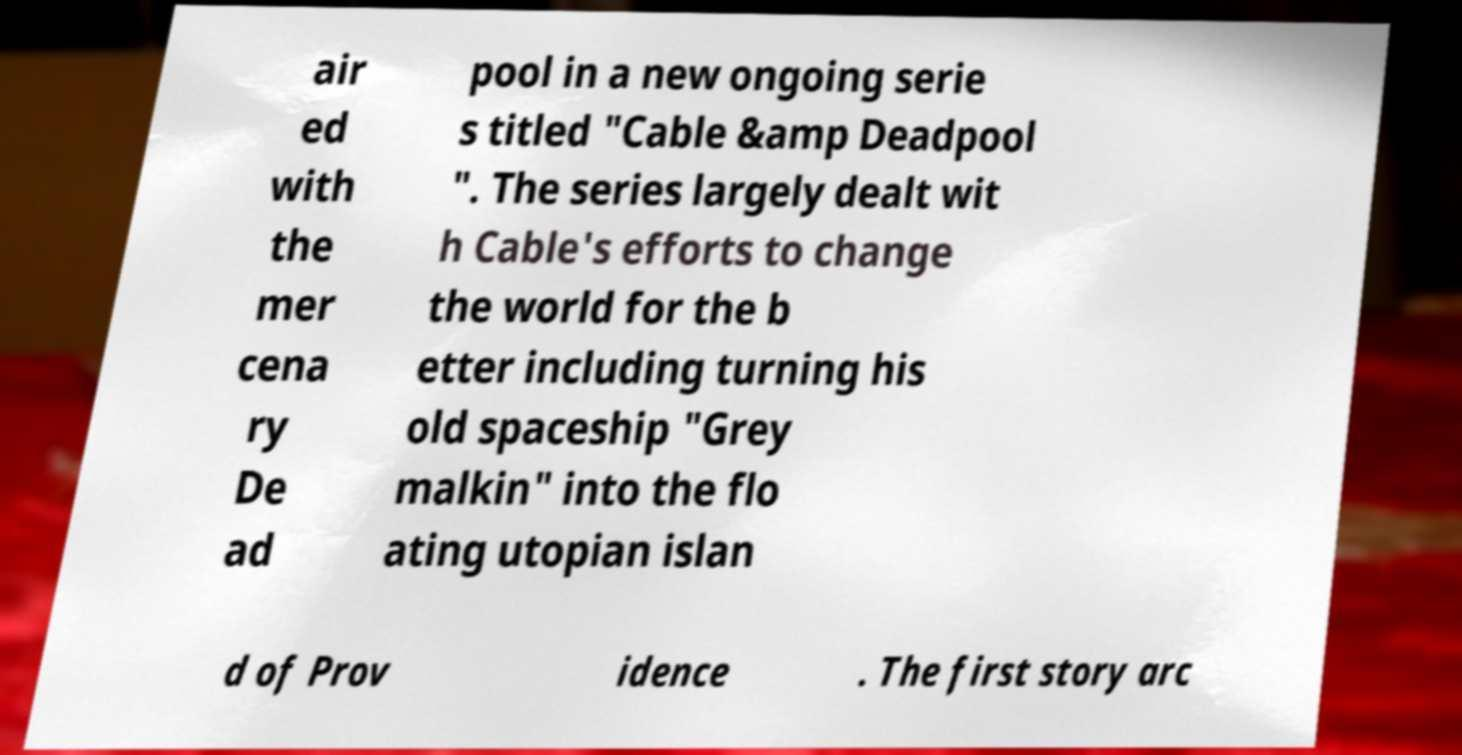Could you assist in decoding the text presented in this image and type it out clearly? air ed with the mer cena ry De ad pool in a new ongoing serie s titled "Cable &amp Deadpool ". The series largely dealt wit h Cable's efforts to change the world for the b etter including turning his old spaceship "Grey malkin" into the flo ating utopian islan d of Prov idence . The first story arc 